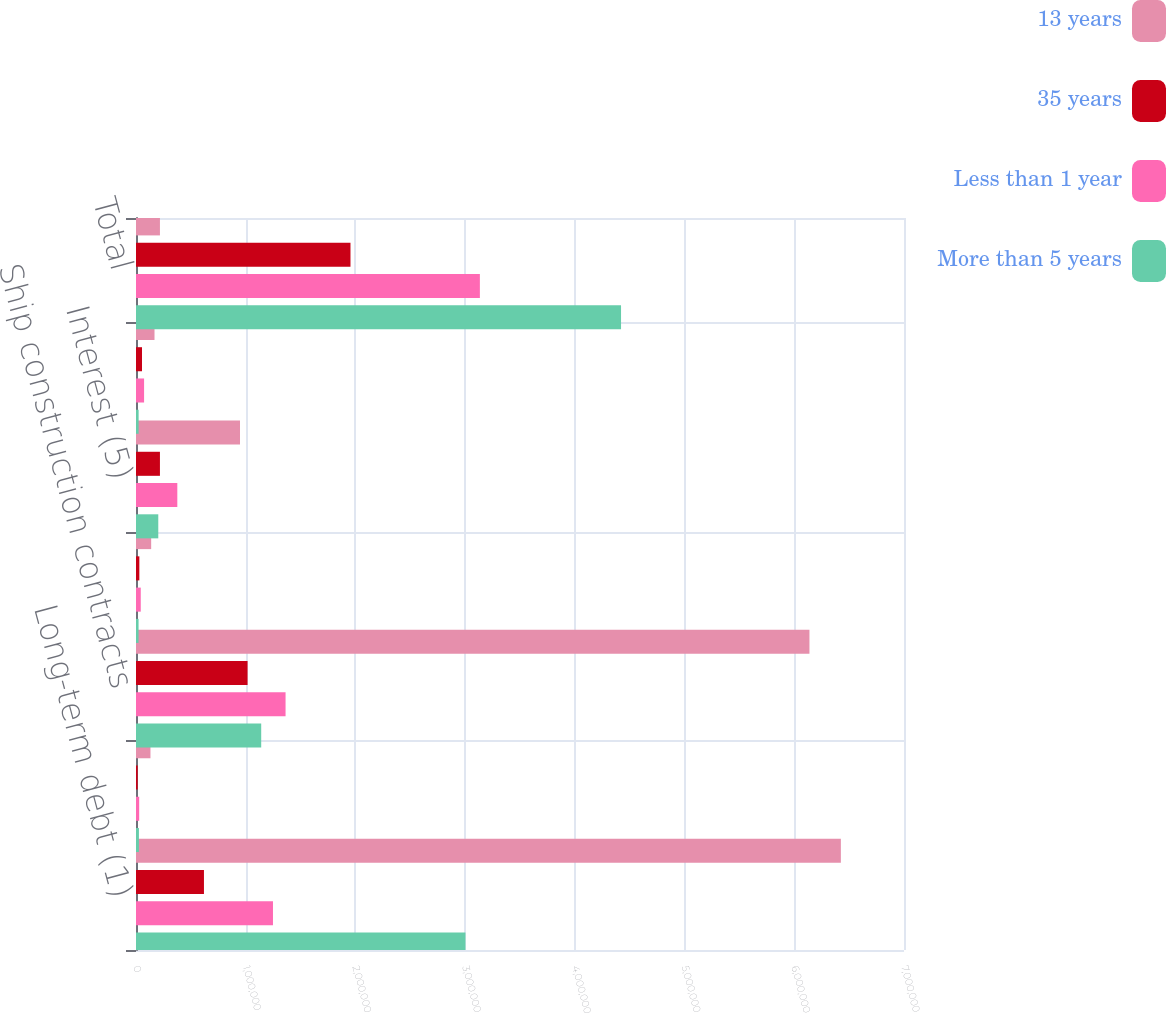Convert chart. <chart><loc_0><loc_0><loc_500><loc_500><stacked_bar_chart><ecel><fcel>Long-term debt (1)<fcel>Operating leases (2)<fcel>Ship construction contracts<fcel>Port facilities (4)<fcel>Interest (5)<fcel>Other (6)<fcel>Total<nl><fcel>13 years<fcel>6.42458e+06<fcel>131791<fcel>6.13822e+06<fcel>138308<fcel>947967<fcel>168678<fcel>218150<nl><fcel>35 years<fcel>619373<fcel>15204<fcel>1.01689e+06<fcel>30509<fcel>218150<fcel>54800<fcel>1.95493e+06<nl><fcel>Less than 1 year<fcel>1.24846e+06<fcel>28973<fcel>1.36322e+06<fcel>43388<fcel>376566<fcel>73653<fcel>3.13426e+06<nl><fcel>More than 5 years<fcel>3.00293e+06<fcel>26504<fcel>1.14121e+06<fcel>23316<fcel>203099<fcel>23870<fcel>4.42093e+06<nl></chart> 